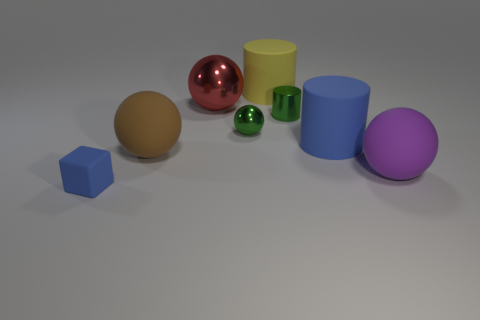How many objects are either green things that are behind the purple matte ball or large brown matte balls?
Ensure brevity in your answer.  3. Does the big cylinder in front of the yellow matte thing have the same color as the tiny cube?
Offer a terse response. Yes. There is a blue matte thing behind the rubber block; what is its size?
Provide a succinct answer. Large. What is the shape of the rubber object behind the green thing on the left side of the yellow matte cylinder?
Keep it short and to the point. Cylinder. What is the color of the other tiny metallic object that is the same shape as the purple object?
Keep it short and to the point. Green. There is a blue thing that is on the right side of the metallic cylinder; is it the same size as the big yellow rubber thing?
Your answer should be very brief. Yes. There is a thing that is the same color as the tiny ball; what is its shape?
Your answer should be very brief. Cylinder. What number of large balls are made of the same material as the green cylinder?
Give a very brief answer. 1. What material is the sphere that is in front of the large matte sphere that is left of the big ball on the right side of the blue cylinder?
Your response must be concise. Rubber. The big ball behind the blue object behind the large purple ball is what color?
Provide a succinct answer. Red. 